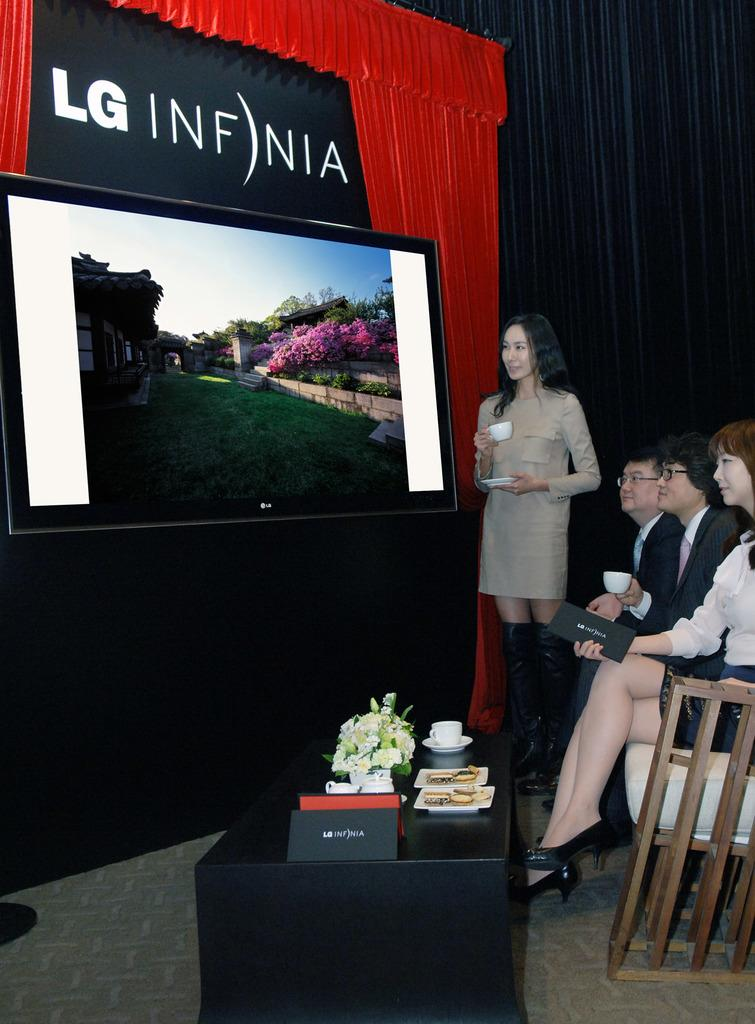<image>
Present a compact description of the photo's key features. People looking at an LG tv with a sign above it that says LG INF)NIA. 